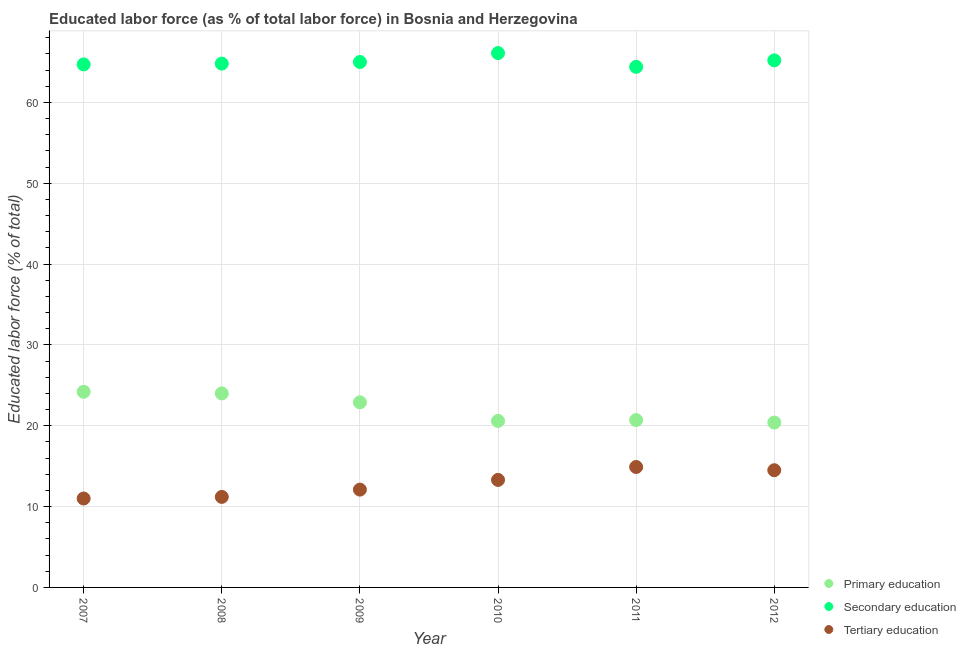Is the number of dotlines equal to the number of legend labels?
Make the answer very short. Yes. What is the percentage of labor force who received secondary education in 2007?
Offer a very short reply. 64.7. Across all years, what is the maximum percentage of labor force who received tertiary education?
Provide a short and direct response. 14.9. Across all years, what is the minimum percentage of labor force who received primary education?
Offer a very short reply. 20.4. In which year was the percentage of labor force who received tertiary education maximum?
Your response must be concise. 2011. What is the total percentage of labor force who received tertiary education in the graph?
Keep it short and to the point. 77. What is the difference between the percentage of labor force who received secondary education in 2008 and that in 2009?
Provide a succinct answer. -0.2. What is the difference between the percentage of labor force who received primary education in 2010 and the percentage of labor force who received tertiary education in 2008?
Offer a terse response. 9.4. What is the average percentage of labor force who received secondary education per year?
Your response must be concise. 65.03. In the year 2012, what is the difference between the percentage of labor force who received primary education and percentage of labor force who received tertiary education?
Give a very brief answer. 5.9. What is the ratio of the percentage of labor force who received primary education in 2008 to that in 2010?
Your answer should be compact. 1.17. What is the difference between the highest and the second highest percentage of labor force who received secondary education?
Give a very brief answer. 0.9. What is the difference between the highest and the lowest percentage of labor force who received secondary education?
Your response must be concise. 1.7. In how many years, is the percentage of labor force who received secondary education greater than the average percentage of labor force who received secondary education taken over all years?
Offer a very short reply. 2. Is it the case that in every year, the sum of the percentage of labor force who received primary education and percentage of labor force who received secondary education is greater than the percentage of labor force who received tertiary education?
Your answer should be very brief. Yes. Does the percentage of labor force who received secondary education monotonically increase over the years?
Offer a terse response. No. Is the percentage of labor force who received tertiary education strictly greater than the percentage of labor force who received secondary education over the years?
Offer a very short reply. No. Is the percentage of labor force who received tertiary education strictly less than the percentage of labor force who received secondary education over the years?
Make the answer very short. Yes. How many years are there in the graph?
Your answer should be very brief. 6. What is the difference between two consecutive major ticks on the Y-axis?
Your response must be concise. 10. Where does the legend appear in the graph?
Offer a terse response. Bottom right. How are the legend labels stacked?
Your answer should be very brief. Vertical. What is the title of the graph?
Ensure brevity in your answer.  Educated labor force (as % of total labor force) in Bosnia and Herzegovina. Does "Labor Market" appear as one of the legend labels in the graph?
Your answer should be compact. No. What is the label or title of the X-axis?
Provide a short and direct response. Year. What is the label or title of the Y-axis?
Offer a very short reply. Educated labor force (% of total). What is the Educated labor force (% of total) of Primary education in 2007?
Provide a short and direct response. 24.2. What is the Educated labor force (% of total) of Secondary education in 2007?
Provide a succinct answer. 64.7. What is the Educated labor force (% of total) in Tertiary education in 2007?
Your answer should be compact. 11. What is the Educated labor force (% of total) of Secondary education in 2008?
Give a very brief answer. 64.8. What is the Educated labor force (% of total) of Tertiary education in 2008?
Give a very brief answer. 11.2. What is the Educated labor force (% of total) of Primary education in 2009?
Keep it short and to the point. 22.9. What is the Educated labor force (% of total) of Secondary education in 2009?
Provide a succinct answer. 65. What is the Educated labor force (% of total) of Tertiary education in 2009?
Your answer should be very brief. 12.1. What is the Educated labor force (% of total) in Primary education in 2010?
Give a very brief answer. 20.6. What is the Educated labor force (% of total) in Secondary education in 2010?
Give a very brief answer. 66.1. What is the Educated labor force (% of total) in Tertiary education in 2010?
Your answer should be compact. 13.3. What is the Educated labor force (% of total) of Primary education in 2011?
Keep it short and to the point. 20.7. What is the Educated labor force (% of total) in Secondary education in 2011?
Provide a succinct answer. 64.4. What is the Educated labor force (% of total) of Tertiary education in 2011?
Make the answer very short. 14.9. What is the Educated labor force (% of total) in Primary education in 2012?
Keep it short and to the point. 20.4. What is the Educated labor force (% of total) of Secondary education in 2012?
Keep it short and to the point. 65.2. What is the Educated labor force (% of total) of Tertiary education in 2012?
Your answer should be compact. 14.5. Across all years, what is the maximum Educated labor force (% of total) of Primary education?
Provide a succinct answer. 24.2. Across all years, what is the maximum Educated labor force (% of total) of Secondary education?
Offer a very short reply. 66.1. Across all years, what is the maximum Educated labor force (% of total) of Tertiary education?
Provide a short and direct response. 14.9. Across all years, what is the minimum Educated labor force (% of total) of Primary education?
Give a very brief answer. 20.4. Across all years, what is the minimum Educated labor force (% of total) of Secondary education?
Your response must be concise. 64.4. What is the total Educated labor force (% of total) in Primary education in the graph?
Provide a succinct answer. 132.8. What is the total Educated labor force (% of total) of Secondary education in the graph?
Your answer should be compact. 390.2. What is the difference between the Educated labor force (% of total) of Secondary education in 2007 and that in 2008?
Offer a very short reply. -0.1. What is the difference between the Educated labor force (% of total) of Secondary education in 2007 and that in 2009?
Your answer should be very brief. -0.3. What is the difference between the Educated labor force (% of total) of Tertiary education in 2007 and that in 2010?
Ensure brevity in your answer.  -2.3. What is the difference between the Educated labor force (% of total) in Primary education in 2007 and that in 2011?
Provide a short and direct response. 3.5. What is the difference between the Educated labor force (% of total) in Secondary education in 2007 and that in 2012?
Make the answer very short. -0.5. What is the difference between the Educated labor force (% of total) of Secondary education in 2008 and that in 2009?
Give a very brief answer. -0.2. What is the difference between the Educated labor force (% of total) of Tertiary education in 2008 and that in 2010?
Ensure brevity in your answer.  -2.1. What is the difference between the Educated labor force (% of total) of Primary education in 2008 and that in 2011?
Give a very brief answer. 3.3. What is the difference between the Educated labor force (% of total) of Secondary education in 2008 and that in 2012?
Provide a short and direct response. -0.4. What is the difference between the Educated labor force (% of total) of Secondary education in 2009 and that in 2010?
Your answer should be compact. -1.1. What is the difference between the Educated labor force (% of total) in Primary education in 2009 and that in 2011?
Keep it short and to the point. 2.2. What is the difference between the Educated labor force (% of total) in Secondary education in 2009 and that in 2011?
Provide a succinct answer. 0.6. What is the difference between the Educated labor force (% of total) of Primary education in 2009 and that in 2012?
Your answer should be very brief. 2.5. What is the difference between the Educated labor force (% of total) in Secondary education in 2009 and that in 2012?
Offer a terse response. -0.2. What is the difference between the Educated labor force (% of total) in Tertiary education in 2009 and that in 2012?
Make the answer very short. -2.4. What is the difference between the Educated labor force (% of total) in Primary education in 2010 and that in 2011?
Provide a short and direct response. -0.1. What is the difference between the Educated labor force (% of total) in Secondary education in 2010 and that in 2011?
Your answer should be very brief. 1.7. What is the difference between the Educated labor force (% of total) in Secondary education in 2010 and that in 2012?
Your answer should be compact. 0.9. What is the difference between the Educated labor force (% of total) of Tertiary education in 2011 and that in 2012?
Keep it short and to the point. 0.4. What is the difference between the Educated labor force (% of total) of Primary education in 2007 and the Educated labor force (% of total) of Secondary education in 2008?
Your response must be concise. -40.6. What is the difference between the Educated labor force (% of total) of Secondary education in 2007 and the Educated labor force (% of total) of Tertiary education in 2008?
Your response must be concise. 53.5. What is the difference between the Educated labor force (% of total) of Primary education in 2007 and the Educated labor force (% of total) of Secondary education in 2009?
Your answer should be very brief. -40.8. What is the difference between the Educated labor force (% of total) in Secondary education in 2007 and the Educated labor force (% of total) in Tertiary education in 2009?
Ensure brevity in your answer.  52.6. What is the difference between the Educated labor force (% of total) of Primary education in 2007 and the Educated labor force (% of total) of Secondary education in 2010?
Provide a short and direct response. -41.9. What is the difference between the Educated labor force (% of total) of Primary education in 2007 and the Educated labor force (% of total) of Tertiary education in 2010?
Your answer should be very brief. 10.9. What is the difference between the Educated labor force (% of total) in Secondary education in 2007 and the Educated labor force (% of total) in Tertiary education in 2010?
Keep it short and to the point. 51.4. What is the difference between the Educated labor force (% of total) in Primary education in 2007 and the Educated labor force (% of total) in Secondary education in 2011?
Offer a very short reply. -40.2. What is the difference between the Educated labor force (% of total) in Secondary education in 2007 and the Educated labor force (% of total) in Tertiary education in 2011?
Offer a very short reply. 49.8. What is the difference between the Educated labor force (% of total) of Primary education in 2007 and the Educated labor force (% of total) of Secondary education in 2012?
Keep it short and to the point. -41. What is the difference between the Educated labor force (% of total) in Secondary education in 2007 and the Educated labor force (% of total) in Tertiary education in 2012?
Ensure brevity in your answer.  50.2. What is the difference between the Educated labor force (% of total) in Primary education in 2008 and the Educated labor force (% of total) in Secondary education in 2009?
Provide a short and direct response. -41. What is the difference between the Educated labor force (% of total) in Secondary education in 2008 and the Educated labor force (% of total) in Tertiary education in 2009?
Your response must be concise. 52.7. What is the difference between the Educated labor force (% of total) in Primary education in 2008 and the Educated labor force (% of total) in Secondary education in 2010?
Offer a very short reply. -42.1. What is the difference between the Educated labor force (% of total) of Secondary education in 2008 and the Educated labor force (% of total) of Tertiary education in 2010?
Your response must be concise. 51.5. What is the difference between the Educated labor force (% of total) in Primary education in 2008 and the Educated labor force (% of total) in Secondary education in 2011?
Make the answer very short. -40.4. What is the difference between the Educated labor force (% of total) of Primary education in 2008 and the Educated labor force (% of total) of Tertiary education in 2011?
Give a very brief answer. 9.1. What is the difference between the Educated labor force (% of total) in Secondary education in 2008 and the Educated labor force (% of total) in Tertiary education in 2011?
Your response must be concise. 49.9. What is the difference between the Educated labor force (% of total) of Primary education in 2008 and the Educated labor force (% of total) of Secondary education in 2012?
Provide a succinct answer. -41.2. What is the difference between the Educated labor force (% of total) of Primary education in 2008 and the Educated labor force (% of total) of Tertiary education in 2012?
Offer a terse response. 9.5. What is the difference between the Educated labor force (% of total) of Secondary education in 2008 and the Educated labor force (% of total) of Tertiary education in 2012?
Your answer should be very brief. 50.3. What is the difference between the Educated labor force (% of total) of Primary education in 2009 and the Educated labor force (% of total) of Secondary education in 2010?
Provide a short and direct response. -43.2. What is the difference between the Educated labor force (% of total) of Primary education in 2009 and the Educated labor force (% of total) of Tertiary education in 2010?
Offer a terse response. 9.6. What is the difference between the Educated labor force (% of total) of Secondary education in 2009 and the Educated labor force (% of total) of Tertiary education in 2010?
Your response must be concise. 51.7. What is the difference between the Educated labor force (% of total) in Primary education in 2009 and the Educated labor force (% of total) in Secondary education in 2011?
Ensure brevity in your answer.  -41.5. What is the difference between the Educated labor force (% of total) in Secondary education in 2009 and the Educated labor force (% of total) in Tertiary education in 2011?
Ensure brevity in your answer.  50.1. What is the difference between the Educated labor force (% of total) of Primary education in 2009 and the Educated labor force (% of total) of Secondary education in 2012?
Ensure brevity in your answer.  -42.3. What is the difference between the Educated labor force (% of total) in Secondary education in 2009 and the Educated labor force (% of total) in Tertiary education in 2012?
Provide a succinct answer. 50.5. What is the difference between the Educated labor force (% of total) in Primary education in 2010 and the Educated labor force (% of total) in Secondary education in 2011?
Your response must be concise. -43.8. What is the difference between the Educated labor force (% of total) of Primary education in 2010 and the Educated labor force (% of total) of Tertiary education in 2011?
Make the answer very short. 5.7. What is the difference between the Educated labor force (% of total) in Secondary education in 2010 and the Educated labor force (% of total) in Tertiary education in 2011?
Your answer should be very brief. 51.2. What is the difference between the Educated labor force (% of total) of Primary education in 2010 and the Educated labor force (% of total) of Secondary education in 2012?
Ensure brevity in your answer.  -44.6. What is the difference between the Educated labor force (% of total) of Primary education in 2010 and the Educated labor force (% of total) of Tertiary education in 2012?
Your answer should be compact. 6.1. What is the difference between the Educated labor force (% of total) of Secondary education in 2010 and the Educated labor force (% of total) of Tertiary education in 2012?
Your response must be concise. 51.6. What is the difference between the Educated labor force (% of total) in Primary education in 2011 and the Educated labor force (% of total) in Secondary education in 2012?
Provide a short and direct response. -44.5. What is the difference between the Educated labor force (% of total) in Secondary education in 2011 and the Educated labor force (% of total) in Tertiary education in 2012?
Provide a short and direct response. 49.9. What is the average Educated labor force (% of total) in Primary education per year?
Offer a very short reply. 22.13. What is the average Educated labor force (% of total) in Secondary education per year?
Give a very brief answer. 65.03. What is the average Educated labor force (% of total) of Tertiary education per year?
Your answer should be compact. 12.83. In the year 2007, what is the difference between the Educated labor force (% of total) in Primary education and Educated labor force (% of total) in Secondary education?
Your response must be concise. -40.5. In the year 2007, what is the difference between the Educated labor force (% of total) of Secondary education and Educated labor force (% of total) of Tertiary education?
Your response must be concise. 53.7. In the year 2008, what is the difference between the Educated labor force (% of total) in Primary education and Educated labor force (% of total) in Secondary education?
Provide a succinct answer. -40.8. In the year 2008, what is the difference between the Educated labor force (% of total) in Primary education and Educated labor force (% of total) in Tertiary education?
Provide a short and direct response. 12.8. In the year 2008, what is the difference between the Educated labor force (% of total) of Secondary education and Educated labor force (% of total) of Tertiary education?
Offer a terse response. 53.6. In the year 2009, what is the difference between the Educated labor force (% of total) in Primary education and Educated labor force (% of total) in Secondary education?
Provide a short and direct response. -42.1. In the year 2009, what is the difference between the Educated labor force (% of total) in Secondary education and Educated labor force (% of total) in Tertiary education?
Offer a terse response. 52.9. In the year 2010, what is the difference between the Educated labor force (% of total) of Primary education and Educated labor force (% of total) of Secondary education?
Offer a very short reply. -45.5. In the year 2010, what is the difference between the Educated labor force (% of total) in Secondary education and Educated labor force (% of total) in Tertiary education?
Your response must be concise. 52.8. In the year 2011, what is the difference between the Educated labor force (% of total) of Primary education and Educated labor force (% of total) of Secondary education?
Make the answer very short. -43.7. In the year 2011, what is the difference between the Educated labor force (% of total) of Secondary education and Educated labor force (% of total) of Tertiary education?
Your response must be concise. 49.5. In the year 2012, what is the difference between the Educated labor force (% of total) in Primary education and Educated labor force (% of total) in Secondary education?
Ensure brevity in your answer.  -44.8. In the year 2012, what is the difference between the Educated labor force (% of total) of Primary education and Educated labor force (% of total) of Tertiary education?
Your response must be concise. 5.9. In the year 2012, what is the difference between the Educated labor force (% of total) of Secondary education and Educated labor force (% of total) of Tertiary education?
Give a very brief answer. 50.7. What is the ratio of the Educated labor force (% of total) in Primary education in 2007 to that in 2008?
Provide a succinct answer. 1.01. What is the ratio of the Educated labor force (% of total) of Secondary education in 2007 to that in 2008?
Offer a terse response. 1. What is the ratio of the Educated labor force (% of total) in Tertiary education in 2007 to that in 2008?
Your answer should be compact. 0.98. What is the ratio of the Educated labor force (% of total) of Primary education in 2007 to that in 2009?
Keep it short and to the point. 1.06. What is the ratio of the Educated labor force (% of total) in Primary education in 2007 to that in 2010?
Keep it short and to the point. 1.17. What is the ratio of the Educated labor force (% of total) of Secondary education in 2007 to that in 2010?
Ensure brevity in your answer.  0.98. What is the ratio of the Educated labor force (% of total) in Tertiary education in 2007 to that in 2010?
Provide a short and direct response. 0.83. What is the ratio of the Educated labor force (% of total) of Primary education in 2007 to that in 2011?
Offer a very short reply. 1.17. What is the ratio of the Educated labor force (% of total) in Tertiary education in 2007 to that in 2011?
Offer a very short reply. 0.74. What is the ratio of the Educated labor force (% of total) in Primary education in 2007 to that in 2012?
Keep it short and to the point. 1.19. What is the ratio of the Educated labor force (% of total) of Tertiary education in 2007 to that in 2012?
Ensure brevity in your answer.  0.76. What is the ratio of the Educated labor force (% of total) in Primary education in 2008 to that in 2009?
Keep it short and to the point. 1.05. What is the ratio of the Educated labor force (% of total) of Tertiary education in 2008 to that in 2009?
Your answer should be compact. 0.93. What is the ratio of the Educated labor force (% of total) in Primary education in 2008 to that in 2010?
Provide a short and direct response. 1.17. What is the ratio of the Educated labor force (% of total) of Secondary education in 2008 to that in 2010?
Offer a terse response. 0.98. What is the ratio of the Educated labor force (% of total) in Tertiary education in 2008 to that in 2010?
Offer a terse response. 0.84. What is the ratio of the Educated labor force (% of total) of Primary education in 2008 to that in 2011?
Your response must be concise. 1.16. What is the ratio of the Educated labor force (% of total) in Secondary education in 2008 to that in 2011?
Your answer should be very brief. 1.01. What is the ratio of the Educated labor force (% of total) of Tertiary education in 2008 to that in 2011?
Provide a short and direct response. 0.75. What is the ratio of the Educated labor force (% of total) of Primary education in 2008 to that in 2012?
Give a very brief answer. 1.18. What is the ratio of the Educated labor force (% of total) in Secondary education in 2008 to that in 2012?
Ensure brevity in your answer.  0.99. What is the ratio of the Educated labor force (% of total) of Tertiary education in 2008 to that in 2012?
Ensure brevity in your answer.  0.77. What is the ratio of the Educated labor force (% of total) in Primary education in 2009 to that in 2010?
Provide a short and direct response. 1.11. What is the ratio of the Educated labor force (% of total) of Secondary education in 2009 to that in 2010?
Ensure brevity in your answer.  0.98. What is the ratio of the Educated labor force (% of total) in Tertiary education in 2009 to that in 2010?
Offer a terse response. 0.91. What is the ratio of the Educated labor force (% of total) of Primary education in 2009 to that in 2011?
Make the answer very short. 1.11. What is the ratio of the Educated labor force (% of total) in Secondary education in 2009 to that in 2011?
Keep it short and to the point. 1.01. What is the ratio of the Educated labor force (% of total) of Tertiary education in 2009 to that in 2011?
Provide a succinct answer. 0.81. What is the ratio of the Educated labor force (% of total) in Primary education in 2009 to that in 2012?
Give a very brief answer. 1.12. What is the ratio of the Educated labor force (% of total) in Secondary education in 2009 to that in 2012?
Your response must be concise. 1. What is the ratio of the Educated labor force (% of total) in Tertiary education in 2009 to that in 2012?
Ensure brevity in your answer.  0.83. What is the ratio of the Educated labor force (% of total) of Secondary education in 2010 to that in 2011?
Provide a succinct answer. 1.03. What is the ratio of the Educated labor force (% of total) of Tertiary education in 2010 to that in 2011?
Make the answer very short. 0.89. What is the ratio of the Educated labor force (% of total) in Primary education in 2010 to that in 2012?
Provide a succinct answer. 1.01. What is the ratio of the Educated labor force (% of total) of Secondary education in 2010 to that in 2012?
Ensure brevity in your answer.  1.01. What is the ratio of the Educated labor force (% of total) of Tertiary education in 2010 to that in 2012?
Offer a terse response. 0.92. What is the ratio of the Educated labor force (% of total) in Primary education in 2011 to that in 2012?
Ensure brevity in your answer.  1.01. What is the ratio of the Educated labor force (% of total) of Secondary education in 2011 to that in 2012?
Offer a very short reply. 0.99. What is the ratio of the Educated labor force (% of total) of Tertiary education in 2011 to that in 2012?
Make the answer very short. 1.03. What is the difference between the highest and the second highest Educated labor force (% of total) of Primary education?
Your answer should be very brief. 0.2. What is the difference between the highest and the second highest Educated labor force (% of total) in Tertiary education?
Keep it short and to the point. 0.4. What is the difference between the highest and the lowest Educated labor force (% of total) of Tertiary education?
Your answer should be very brief. 3.9. 